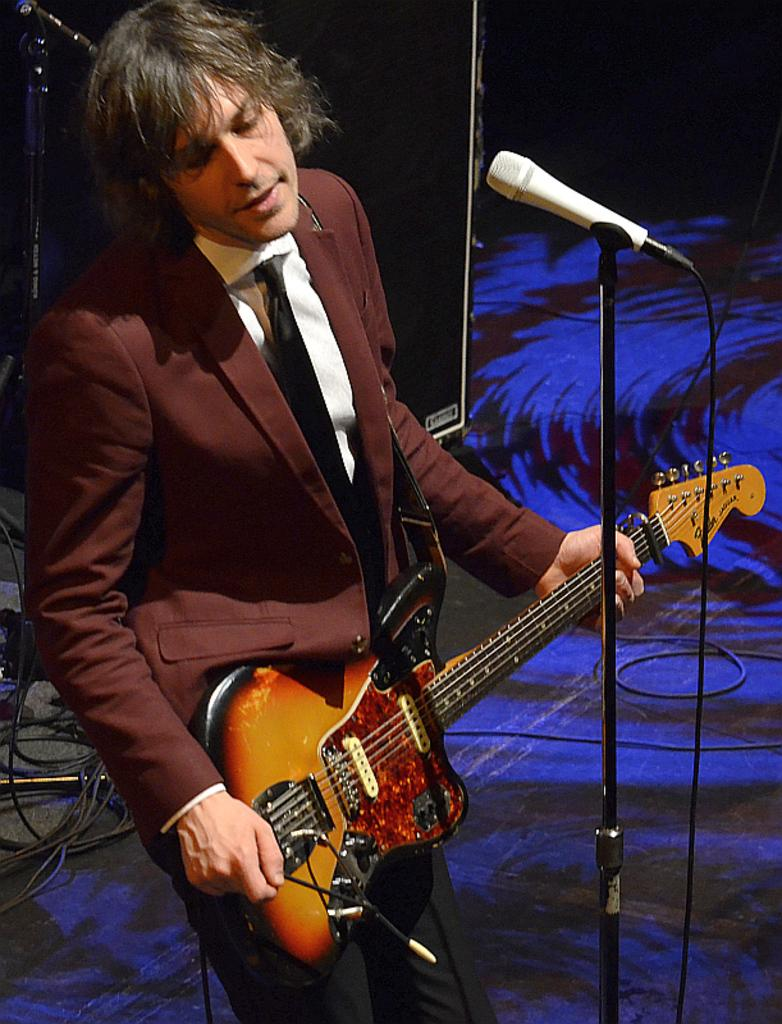What is the man in the image doing? The man is playing a guitar. What object is present in the image that is typically used for amplifying sound? There is a microphone in the image. Can you see any children playing with a ship in the image? There are no children or ships present in the image. Is there a drain visible in the image? There is no drain visible in the image. 